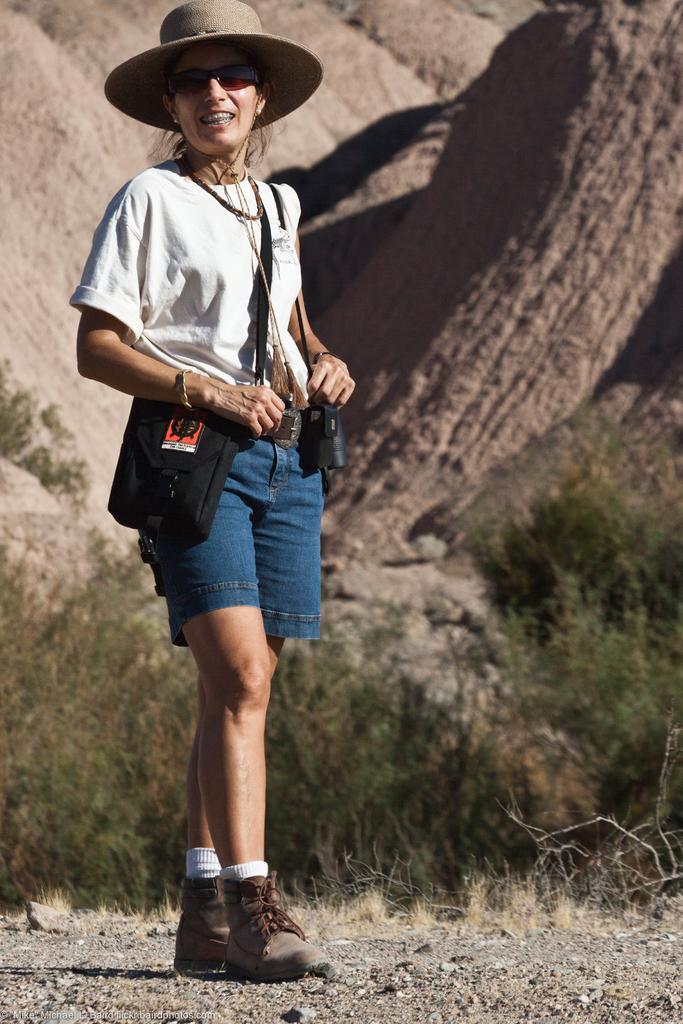How would you summarize this image in a sentence or two? In this image we can see a lady. The lady is wearing a hat and carries a bag. Behind the lady we can see a group of plants and rocks. 